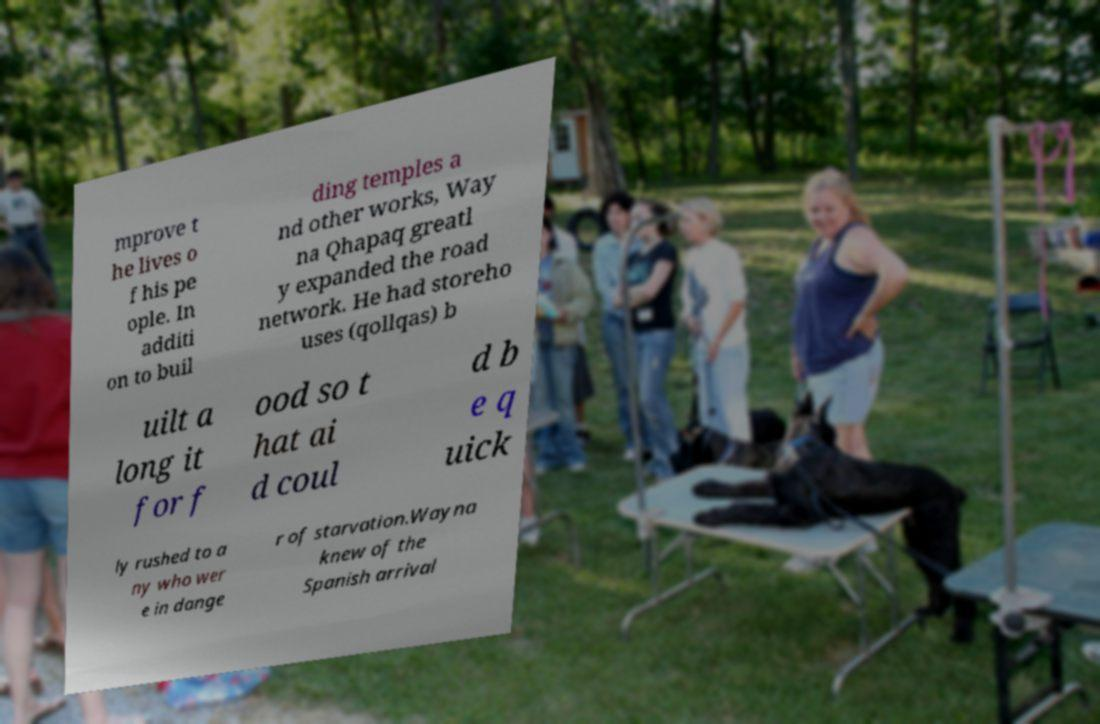I need the written content from this picture converted into text. Can you do that? mprove t he lives o f his pe ople. In additi on to buil ding temples a nd other works, Way na Qhapaq greatl y expanded the road network. He had storeho uses (qollqas) b uilt a long it for f ood so t hat ai d coul d b e q uick ly rushed to a ny who wer e in dange r of starvation.Wayna knew of the Spanish arrival 